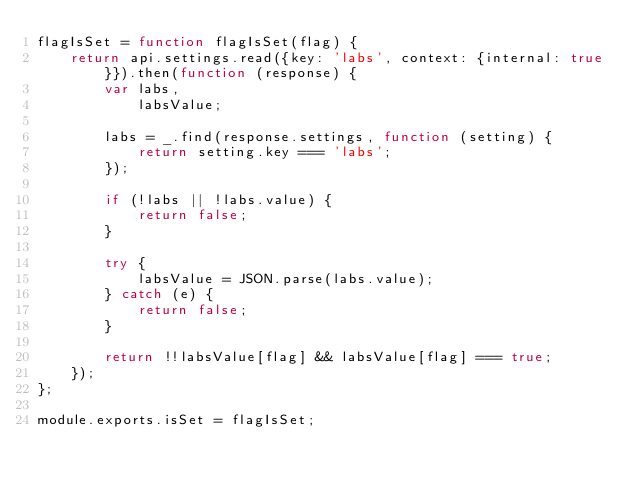<code> <loc_0><loc_0><loc_500><loc_500><_JavaScript_>flagIsSet = function flagIsSet(flag) {
    return api.settings.read({key: 'labs', context: {internal: true}}).then(function (response) {
        var labs,
            labsValue;

        labs = _.find(response.settings, function (setting) {
            return setting.key === 'labs';
        });

        if (!labs || !labs.value) {
            return false;
        }

        try {
            labsValue = JSON.parse(labs.value);
        } catch (e) {
            return false;
        }

        return !!labsValue[flag] && labsValue[flag] === true;
    });
};

module.exports.isSet = flagIsSet;
</code> 